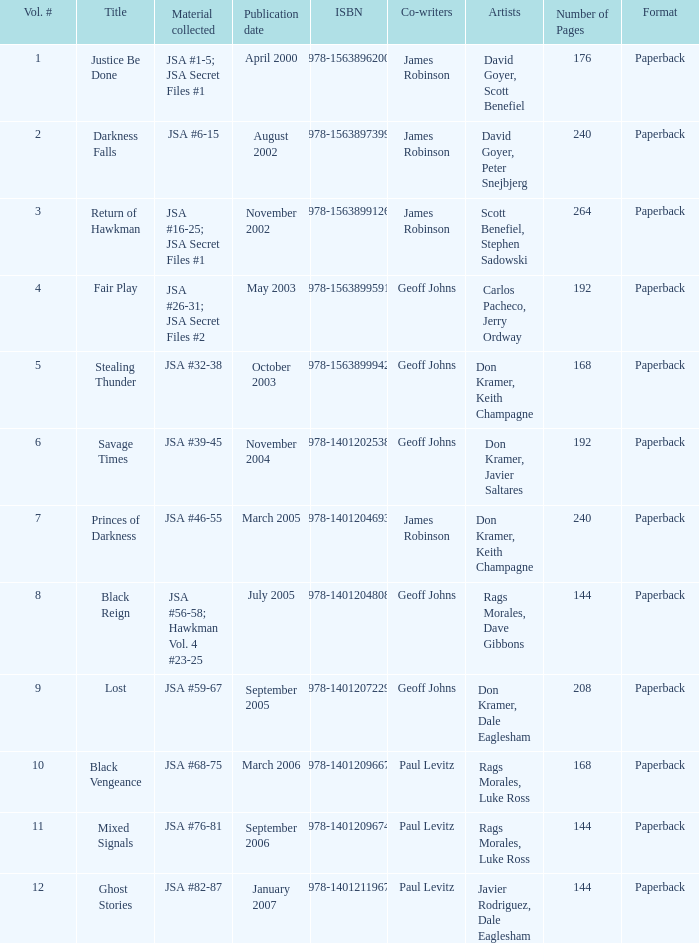Could you parse the entire table as a dict? {'header': ['Vol. #', 'Title', 'Material collected', 'Publication date', 'ISBN', 'Co-writers', 'Artists', 'Number of Pages', 'Format'], 'rows': [['1', 'Justice Be Done', 'JSA #1-5; JSA Secret Files #1', 'April 2000', '978-1563896200', 'James Robinson', 'David Goyer, Scott Benefiel', '176', 'Paperback'], ['2', 'Darkness Falls', 'JSA #6-15', 'August 2002', '978-1563897399', 'James Robinson', 'David Goyer, Peter Snejbjerg', '240', 'Paperback'], ['3', 'Return of Hawkman', 'JSA #16-25; JSA Secret Files #1', 'November 2002', '978-1563899126', 'James Robinson', 'Scott Benefiel, Stephen Sadowski', '264', 'Paperback'], ['4', 'Fair Play', 'JSA #26-31; JSA Secret Files #2', 'May 2003', '978-1563899591', 'Geoff Johns', 'Carlos Pacheco, Jerry Ordway', '192', 'Paperback'], ['5', 'Stealing Thunder', 'JSA #32-38', 'October 2003', '978-1563899942', 'Geoff Johns', 'Don Kramer, Keith Champagne', '168', 'Paperback'], ['6', 'Savage Times', 'JSA #39-45', 'November 2004', '978-1401202538', 'Geoff Johns', 'Don Kramer, Javier Saltares', '192', 'Paperback'], ['7', 'Princes of Darkness', 'JSA #46-55', 'March 2005', '978-1401204693', 'James Robinson', 'Don Kramer, Keith Champagne', '240', 'Paperback'], ['8', 'Black Reign', 'JSA #56-58; Hawkman Vol. 4 #23-25', 'July 2005', '978-1401204808', 'Geoff Johns', 'Rags Morales, Dave Gibbons', '144', 'Paperback'], ['9', 'Lost', 'JSA #59-67', 'September 2005', '978-1401207229', 'Geoff Johns', 'Don Kramer, Dale Eaglesham', '208', 'Paperback'], ['10', 'Black Vengeance', 'JSA #68-75', 'March 2006', '978-1401209667', 'Paul Levitz', 'Rags Morales, Luke Ross', '168', 'Paperback'], ['11', 'Mixed Signals', 'JSA #76-81', 'September 2006', '978-1401209674', 'Paul Levitz', 'Rags Morales, Luke Ross', '144', 'Paperback'], ['12', 'Ghost Stories', 'JSA #82-87', 'January 2007', '978-1401211967', 'Paul Levitz', 'Javier Rodriguez, Dale Eaglesham', '144', 'Paperback']]} What's the Material collected for the 978-1401209674 ISBN? JSA #76-81. 